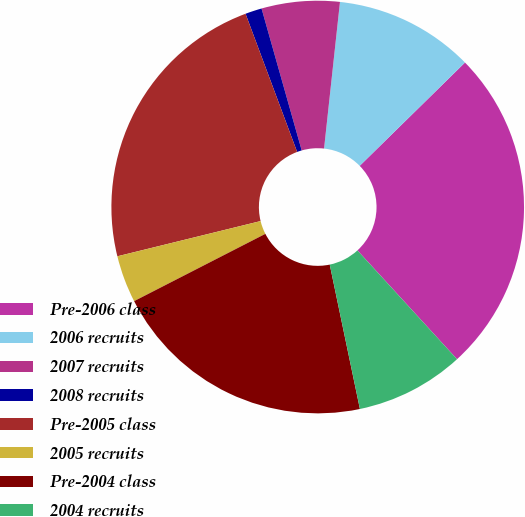Convert chart. <chart><loc_0><loc_0><loc_500><loc_500><pie_chart><fcel>Pre-2006 class<fcel>2006 recruits<fcel>2007 recruits<fcel>2008 recruits<fcel>Pre-2005 class<fcel>2005 recruits<fcel>Pre-2004 class<fcel>2004 recruits<nl><fcel>25.55%<fcel>10.93%<fcel>6.11%<fcel>1.3%<fcel>23.15%<fcel>3.7%<fcel>20.74%<fcel>8.52%<nl></chart> 